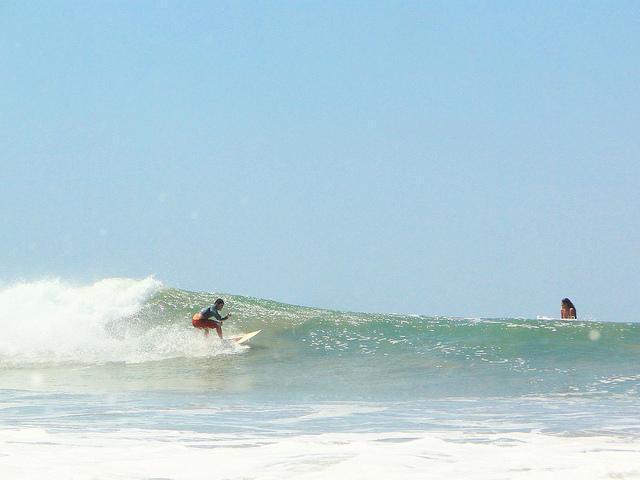How many brown horses are jumping in this photo?
Give a very brief answer. 0. 